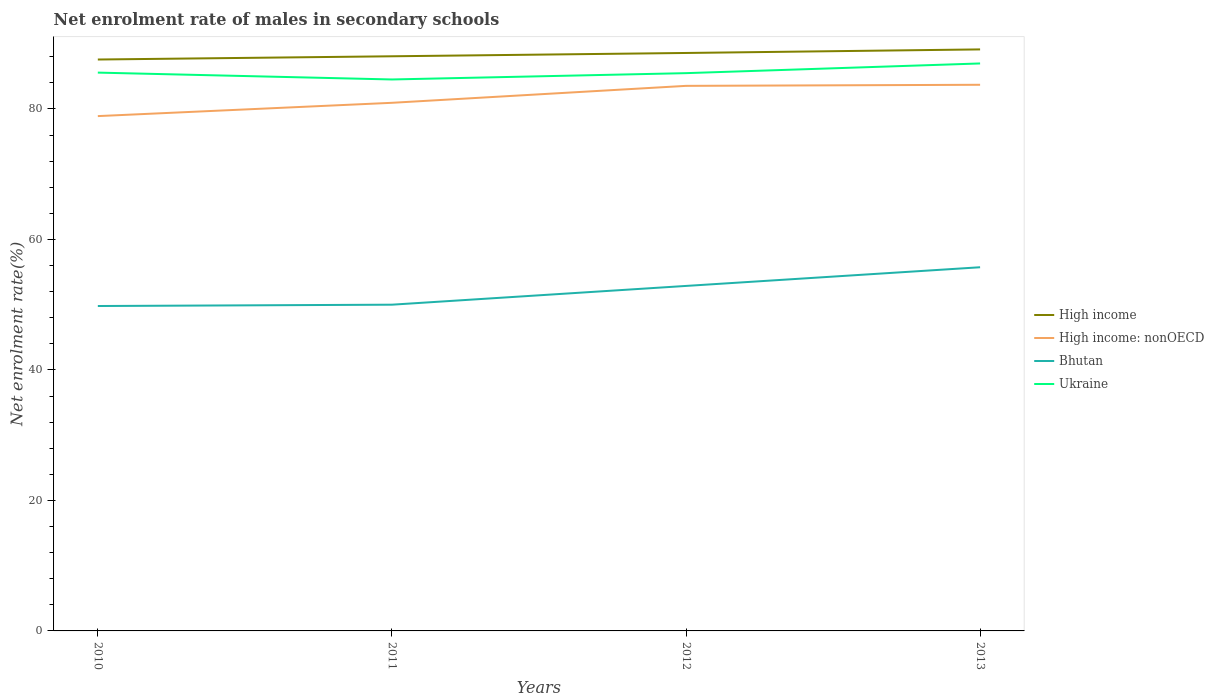Is the number of lines equal to the number of legend labels?
Ensure brevity in your answer.  Yes. Across all years, what is the maximum net enrolment rate of males in secondary schools in High income: nonOECD?
Offer a very short reply. 78.91. In which year was the net enrolment rate of males in secondary schools in Bhutan maximum?
Ensure brevity in your answer.  2010. What is the total net enrolment rate of males in secondary schools in Bhutan in the graph?
Your answer should be very brief. -5.74. What is the difference between the highest and the second highest net enrolment rate of males in secondary schools in High income?
Give a very brief answer. 1.55. Is the net enrolment rate of males in secondary schools in High income strictly greater than the net enrolment rate of males in secondary schools in Bhutan over the years?
Your response must be concise. No. How many lines are there?
Your answer should be very brief. 4. Does the graph contain any zero values?
Ensure brevity in your answer.  No. Does the graph contain grids?
Provide a short and direct response. No. How many legend labels are there?
Provide a short and direct response. 4. What is the title of the graph?
Your answer should be very brief. Net enrolment rate of males in secondary schools. Does "Lower middle income" appear as one of the legend labels in the graph?
Provide a succinct answer. No. What is the label or title of the Y-axis?
Provide a succinct answer. Net enrolment rate(%). What is the Net enrolment rate(%) of High income in 2010?
Provide a short and direct response. 87.58. What is the Net enrolment rate(%) of High income: nonOECD in 2010?
Ensure brevity in your answer.  78.91. What is the Net enrolment rate(%) of Bhutan in 2010?
Your response must be concise. 49.8. What is the Net enrolment rate(%) of Ukraine in 2010?
Keep it short and to the point. 85.57. What is the Net enrolment rate(%) of High income in 2011?
Make the answer very short. 88.08. What is the Net enrolment rate(%) of High income: nonOECD in 2011?
Give a very brief answer. 80.94. What is the Net enrolment rate(%) of Bhutan in 2011?
Your answer should be very brief. 50. What is the Net enrolment rate(%) of Ukraine in 2011?
Give a very brief answer. 84.52. What is the Net enrolment rate(%) of High income in 2012?
Provide a succinct answer. 88.58. What is the Net enrolment rate(%) of High income: nonOECD in 2012?
Your response must be concise. 83.54. What is the Net enrolment rate(%) of Bhutan in 2012?
Offer a very short reply. 52.88. What is the Net enrolment rate(%) in Ukraine in 2012?
Your answer should be compact. 85.49. What is the Net enrolment rate(%) in High income in 2013?
Your response must be concise. 89.13. What is the Net enrolment rate(%) in High income: nonOECD in 2013?
Ensure brevity in your answer.  83.71. What is the Net enrolment rate(%) of Bhutan in 2013?
Your response must be concise. 55.74. What is the Net enrolment rate(%) in Ukraine in 2013?
Your answer should be compact. 86.98. Across all years, what is the maximum Net enrolment rate(%) in High income?
Your answer should be compact. 89.13. Across all years, what is the maximum Net enrolment rate(%) in High income: nonOECD?
Offer a very short reply. 83.71. Across all years, what is the maximum Net enrolment rate(%) in Bhutan?
Offer a terse response. 55.74. Across all years, what is the maximum Net enrolment rate(%) in Ukraine?
Your answer should be very brief. 86.98. Across all years, what is the minimum Net enrolment rate(%) of High income?
Provide a succinct answer. 87.58. Across all years, what is the minimum Net enrolment rate(%) in High income: nonOECD?
Your response must be concise. 78.91. Across all years, what is the minimum Net enrolment rate(%) of Bhutan?
Give a very brief answer. 49.8. Across all years, what is the minimum Net enrolment rate(%) in Ukraine?
Provide a short and direct response. 84.52. What is the total Net enrolment rate(%) in High income in the graph?
Your response must be concise. 353.37. What is the total Net enrolment rate(%) of High income: nonOECD in the graph?
Offer a terse response. 327.1. What is the total Net enrolment rate(%) in Bhutan in the graph?
Give a very brief answer. 208.42. What is the total Net enrolment rate(%) of Ukraine in the graph?
Ensure brevity in your answer.  342.56. What is the difference between the Net enrolment rate(%) in High income in 2010 and that in 2011?
Your answer should be compact. -0.5. What is the difference between the Net enrolment rate(%) in High income: nonOECD in 2010 and that in 2011?
Give a very brief answer. -2.04. What is the difference between the Net enrolment rate(%) of Bhutan in 2010 and that in 2011?
Keep it short and to the point. -0.2. What is the difference between the Net enrolment rate(%) in Ukraine in 2010 and that in 2011?
Your answer should be compact. 1.05. What is the difference between the Net enrolment rate(%) of High income in 2010 and that in 2012?
Offer a very short reply. -1. What is the difference between the Net enrolment rate(%) in High income: nonOECD in 2010 and that in 2012?
Provide a short and direct response. -4.63. What is the difference between the Net enrolment rate(%) of Bhutan in 2010 and that in 2012?
Your answer should be compact. -3.08. What is the difference between the Net enrolment rate(%) in Ukraine in 2010 and that in 2012?
Your answer should be compact. 0.08. What is the difference between the Net enrolment rate(%) in High income in 2010 and that in 2013?
Offer a very short reply. -1.55. What is the difference between the Net enrolment rate(%) of High income: nonOECD in 2010 and that in 2013?
Ensure brevity in your answer.  -4.8. What is the difference between the Net enrolment rate(%) in Bhutan in 2010 and that in 2013?
Make the answer very short. -5.94. What is the difference between the Net enrolment rate(%) of Ukraine in 2010 and that in 2013?
Offer a terse response. -1.4. What is the difference between the Net enrolment rate(%) of High income in 2011 and that in 2012?
Your response must be concise. -0.51. What is the difference between the Net enrolment rate(%) of High income: nonOECD in 2011 and that in 2012?
Your answer should be very brief. -2.6. What is the difference between the Net enrolment rate(%) in Bhutan in 2011 and that in 2012?
Offer a very short reply. -2.87. What is the difference between the Net enrolment rate(%) in Ukraine in 2011 and that in 2012?
Your answer should be very brief. -0.97. What is the difference between the Net enrolment rate(%) in High income in 2011 and that in 2013?
Ensure brevity in your answer.  -1.05. What is the difference between the Net enrolment rate(%) of High income: nonOECD in 2011 and that in 2013?
Make the answer very short. -2.76. What is the difference between the Net enrolment rate(%) of Bhutan in 2011 and that in 2013?
Your response must be concise. -5.74. What is the difference between the Net enrolment rate(%) in Ukraine in 2011 and that in 2013?
Provide a succinct answer. -2.45. What is the difference between the Net enrolment rate(%) in High income in 2012 and that in 2013?
Your answer should be compact. -0.55. What is the difference between the Net enrolment rate(%) in High income: nonOECD in 2012 and that in 2013?
Keep it short and to the point. -0.17. What is the difference between the Net enrolment rate(%) in Bhutan in 2012 and that in 2013?
Provide a short and direct response. -2.86. What is the difference between the Net enrolment rate(%) of Ukraine in 2012 and that in 2013?
Provide a succinct answer. -1.48. What is the difference between the Net enrolment rate(%) in High income in 2010 and the Net enrolment rate(%) in High income: nonOECD in 2011?
Ensure brevity in your answer.  6.64. What is the difference between the Net enrolment rate(%) of High income in 2010 and the Net enrolment rate(%) of Bhutan in 2011?
Your answer should be compact. 37.58. What is the difference between the Net enrolment rate(%) of High income in 2010 and the Net enrolment rate(%) of Ukraine in 2011?
Offer a very short reply. 3.06. What is the difference between the Net enrolment rate(%) in High income: nonOECD in 2010 and the Net enrolment rate(%) in Bhutan in 2011?
Make the answer very short. 28.9. What is the difference between the Net enrolment rate(%) of High income: nonOECD in 2010 and the Net enrolment rate(%) of Ukraine in 2011?
Your answer should be compact. -5.61. What is the difference between the Net enrolment rate(%) of Bhutan in 2010 and the Net enrolment rate(%) of Ukraine in 2011?
Your answer should be compact. -34.72. What is the difference between the Net enrolment rate(%) of High income in 2010 and the Net enrolment rate(%) of High income: nonOECD in 2012?
Your answer should be very brief. 4.04. What is the difference between the Net enrolment rate(%) of High income in 2010 and the Net enrolment rate(%) of Bhutan in 2012?
Provide a succinct answer. 34.7. What is the difference between the Net enrolment rate(%) in High income in 2010 and the Net enrolment rate(%) in Ukraine in 2012?
Give a very brief answer. 2.09. What is the difference between the Net enrolment rate(%) in High income: nonOECD in 2010 and the Net enrolment rate(%) in Bhutan in 2012?
Keep it short and to the point. 26.03. What is the difference between the Net enrolment rate(%) in High income: nonOECD in 2010 and the Net enrolment rate(%) in Ukraine in 2012?
Provide a short and direct response. -6.58. What is the difference between the Net enrolment rate(%) of Bhutan in 2010 and the Net enrolment rate(%) of Ukraine in 2012?
Your answer should be very brief. -35.69. What is the difference between the Net enrolment rate(%) of High income in 2010 and the Net enrolment rate(%) of High income: nonOECD in 2013?
Offer a very short reply. 3.87. What is the difference between the Net enrolment rate(%) of High income in 2010 and the Net enrolment rate(%) of Bhutan in 2013?
Provide a short and direct response. 31.84. What is the difference between the Net enrolment rate(%) of High income in 2010 and the Net enrolment rate(%) of Ukraine in 2013?
Keep it short and to the point. 0.61. What is the difference between the Net enrolment rate(%) in High income: nonOECD in 2010 and the Net enrolment rate(%) in Bhutan in 2013?
Offer a terse response. 23.17. What is the difference between the Net enrolment rate(%) of High income: nonOECD in 2010 and the Net enrolment rate(%) of Ukraine in 2013?
Offer a very short reply. -8.07. What is the difference between the Net enrolment rate(%) of Bhutan in 2010 and the Net enrolment rate(%) of Ukraine in 2013?
Make the answer very short. -37.18. What is the difference between the Net enrolment rate(%) of High income in 2011 and the Net enrolment rate(%) of High income: nonOECD in 2012?
Make the answer very short. 4.54. What is the difference between the Net enrolment rate(%) of High income in 2011 and the Net enrolment rate(%) of Bhutan in 2012?
Your answer should be very brief. 35.2. What is the difference between the Net enrolment rate(%) of High income in 2011 and the Net enrolment rate(%) of Ukraine in 2012?
Ensure brevity in your answer.  2.59. What is the difference between the Net enrolment rate(%) in High income: nonOECD in 2011 and the Net enrolment rate(%) in Bhutan in 2012?
Offer a very short reply. 28.07. What is the difference between the Net enrolment rate(%) in High income: nonOECD in 2011 and the Net enrolment rate(%) in Ukraine in 2012?
Give a very brief answer. -4.55. What is the difference between the Net enrolment rate(%) of Bhutan in 2011 and the Net enrolment rate(%) of Ukraine in 2012?
Provide a succinct answer. -35.49. What is the difference between the Net enrolment rate(%) of High income in 2011 and the Net enrolment rate(%) of High income: nonOECD in 2013?
Ensure brevity in your answer.  4.37. What is the difference between the Net enrolment rate(%) of High income in 2011 and the Net enrolment rate(%) of Bhutan in 2013?
Give a very brief answer. 32.34. What is the difference between the Net enrolment rate(%) of High income in 2011 and the Net enrolment rate(%) of Ukraine in 2013?
Keep it short and to the point. 1.1. What is the difference between the Net enrolment rate(%) in High income: nonOECD in 2011 and the Net enrolment rate(%) in Bhutan in 2013?
Your response must be concise. 25.21. What is the difference between the Net enrolment rate(%) in High income: nonOECD in 2011 and the Net enrolment rate(%) in Ukraine in 2013?
Ensure brevity in your answer.  -6.03. What is the difference between the Net enrolment rate(%) in Bhutan in 2011 and the Net enrolment rate(%) in Ukraine in 2013?
Keep it short and to the point. -36.97. What is the difference between the Net enrolment rate(%) of High income in 2012 and the Net enrolment rate(%) of High income: nonOECD in 2013?
Provide a short and direct response. 4.87. What is the difference between the Net enrolment rate(%) of High income in 2012 and the Net enrolment rate(%) of Bhutan in 2013?
Your response must be concise. 32.84. What is the difference between the Net enrolment rate(%) of High income in 2012 and the Net enrolment rate(%) of Ukraine in 2013?
Make the answer very short. 1.61. What is the difference between the Net enrolment rate(%) of High income: nonOECD in 2012 and the Net enrolment rate(%) of Bhutan in 2013?
Provide a short and direct response. 27.8. What is the difference between the Net enrolment rate(%) of High income: nonOECD in 2012 and the Net enrolment rate(%) of Ukraine in 2013?
Provide a succinct answer. -3.43. What is the difference between the Net enrolment rate(%) of Bhutan in 2012 and the Net enrolment rate(%) of Ukraine in 2013?
Ensure brevity in your answer.  -34.1. What is the average Net enrolment rate(%) in High income per year?
Make the answer very short. 88.34. What is the average Net enrolment rate(%) of High income: nonOECD per year?
Give a very brief answer. 81.78. What is the average Net enrolment rate(%) in Bhutan per year?
Give a very brief answer. 52.1. What is the average Net enrolment rate(%) of Ukraine per year?
Provide a succinct answer. 85.64. In the year 2010, what is the difference between the Net enrolment rate(%) in High income and Net enrolment rate(%) in High income: nonOECD?
Give a very brief answer. 8.67. In the year 2010, what is the difference between the Net enrolment rate(%) of High income and Net enrolment rate(%) of Bhutan?
Give a very brief answer. 37.78. In the year 2010, what is the difference between the Net enrolment rate(%) in High income and Net enrolment rate(%) in Ukraine?
Offer a terse response. 2.01. In the year 2010, what is the difference between the Net enrolment rate(%) of High income: nonOECD and Net enrolment rate(%) of Bhutan?
Provide a short and direct response. 29.11. In the year 2010, what is the difference between the Net enrolment rate(%) of High income: nonOECD and Net enrolment rate(%) of Ukraine?
Your answer should be compact. -6.67. In the year 2010, what is the difference between the Net enrolment rate(%) of Bhutan and Net enrolment rate(%) of Ukraine?
Offer a terse response. -35.77. In the year 2011, what is the difference between the Net enrolment rate(%) in High income and Net enrolment rate(%) in High income: nonOECD?
Provide a succinct answer. 7.13. In the year 2011, what is the difference between the Net enrolment rate(%) of High income and Net enrolment rate(%) of Bhutan?
Your response must be concise. 38.07. In the year 2011, what is the difference between the Net enrolment rate(%) in High income and Net enrolment rate(%) in Ukraine?
Your response must be concise. 3.56. In the year 2011, what is the difference between the Net enrolment rate(%) of High income: nonOECD and Net enrolment rate(%) of Bhutan?
Your answer should be compact. 30.94. In the year 2011, what is the difference between the Net enrolment rate(%) in High income: nonOECD and Net enrolment rate(%) in Ukraine?
Keep it short and to the point. -3.58. In the year 2011, what is the difference between the Net enrolment rate(%) in Bhutan and Net enrolment rate(%) in Ukraine?
Offer a very short reply. -34.52. In the year 2012, what is the difference between the Net enrolment rate(%) in High income and Net enrolment rate(%) in High income: nonOECD?
Keep it short and to the point. 5.04. In the year 2012, what is the difference between the Net enrolment rate(%) in High income and Net enrolment rate(%) in Bhutan?
Your answer should be very brief. 35.71. In the year 2012, what is the difference between the Net enrolment rate(%) of High income and Net enrolment rate(%) of Ukraine?
Your response must be concise. 3.09. In the year 2012, what is the difference between the Net enrolment rate(%) of High income: nonOECD and Net enrolment rate(%) of Bhutan?
Make the answer very short. 30.66. In the year 2012, what is the difference between the Net enrolment rate(%) of High income: nonOECD and Net enrolment rate(%) of Ukraine?
Provide a succinct answer. -1.95. In the year 2012, what is the difference between the Net enrolment rate(%) of Bhutan and Net enrolment rate(%) of Ukraine?
Give a very brief answer. -32.61. In the year 2013, what is the difference between the Net enrolment rate(%) of High income and Net enrolment rate(%) of High income: nonOECD?
Offer a terse response. 5.42. In the year 2013, what is the difference between the Net enrolment rate(%) in High income and Net enrolment rate(%) in Bhutan?
Offer a very short reply. 33.39. In the year 2013, what is the difference between the Net enrolment rate(%) of High income and Net enrolment rate(%) of Ukraine?
Make the answer very short. 2.15. In the year 2013, what is the difference between the Net enrolment rate(%) of High income: nonOECD and Net enrolment rate(%) of Bhutan?
Provide a succinct answer. 27.97. In the year 2013, what is the difference between the Net enrolment rate(%) of High income: nonOECD and Net enrolment rate(%) of Ukraine?
Make the answer very short. -3.27. In the year 2013, what is the difference between the Net enrolment rate(%) in Bhutan and Net enrolment rate(%) in Ukraine?
Make the answer very short. -31.24. What is the ratio of the Net enrolment rate(%) in High income in 2010 to that in 2011?
Give a very brief answer. 0.99. What is the ratio of the Net enrolment rate(%) of High income: nonOECD in 2010 to that in 2011?
Offer a very short reply. 0.97. What is the ratio of the Net enrolment rate(%) in Ukraine in 2010 to that in 2011?
Your response must be concise. 1.01. What is the ratio of the Net enrolment rate(%) of High income in 2010 to that in 2012?
Make the answer very short. 0.99. What is the ratio of the Net enrolment rate(%) of High income: nonOECD in 2010 to that in 2012?
Ensure brevity in your answer.  0.94. What is the ratio of the Net enrolment rate(%) of Bhutan in 2010 to that in 2012?
Keep it short and to the point. 0.94. What is the ratio of the Net enrolment rate(%) in High income in 2010 to that in 2013?
Give a very brief answer. 0.98. What is the ratio of the Net enrolment rate(%) of High income: nonOECD in 2010 to that in 2013?
Your answer should be compact. 0.94. What is the ratio of the Net enrolment rate(%) of Bhutan in 2010 to that in 2013?
Offer a terse response. 0.89. What is the ratio of the Net enrolment rate(%) of Ukraine in 2010 to that in 2013?
Ensure brevity in your answer.  0.98. What is the ratio of the Net enrolment rate(%) of High income: nonOECD in 2011 to that in 2012?
Offer a terse response. 0.97. What is the ratio of the Net enrolment rate(%) of Bhutan in 2011 to that in 2012?
Your answer should be very brief. 0.95. What is the ratio of the Net enrolment rate(%) in Ukraine in 2011 to that in 2012?
Your answer should be very brief. 0.99. What is the ratio of the Net enrolment rate(%) of High income in 2011 to that in 2013?
Offer a very short reply. 0.99. What is the ratio of the Net enrolment rate(%) in High income: nonOECD in 2011 to that in 2013?
Offer a terse response. 0.97. What is the ratio of the Net enrolment rate(%) in Bhutan in 2011 to that in 2013?
Provide a succinct answer. 0.9. What is the ratio of the Net enrolment rate(%) in Ukraine in 2011 to that in 2013?
Provide a succinct answer. 0.97. What is the ratio of the Net enrolment rate(%) in High income in 2012 to that in 2013?
Keep it short and to the point. 0.99. What is the ratio of the Net enrolment rate(%) of Bhutan in 2012 to that in 2013?
Offer a very short reply. 0.95. What is the ratio of the Net enrolment rate(%) of Ukraine in 2012 to that in 2013?
Offer a very short reply. 0.98. What is the difference between the highest and the second highest Net enrolment rate(%) of High income?
Your answer should be very brief. 0.55. What is the difference between the highest and the second highest Net enrolment rate(%) in High income: nonOECD?
Offer a terse response. 0.17. What is the difference between the highest and the second highest Net enrolment rate(%) in Bhutan?
Offer a very short reply. 2.86. What is the difference between the highest and the second highest Net enrolment rate(%) of Ukraine?
Your answer should be very brief. 1.4. What is the difference between the highest and the lowest Net enrolment rate(%) in High income?
Make the answer very short. 1.55. What is the difference between the highest and the lowest Net enrolment rate(%) in High income: nonOECD?
Offer a very short reply. 4.8. What is the difference between the highest and the lowest Net enrolment rate(%) of Bhutan?
Provide a succinct answer. 5.94. What is the difference between the highest and the lowest Net enrolment rate(%) in Ukraine?
Keep it short and to the point. 2.45. 